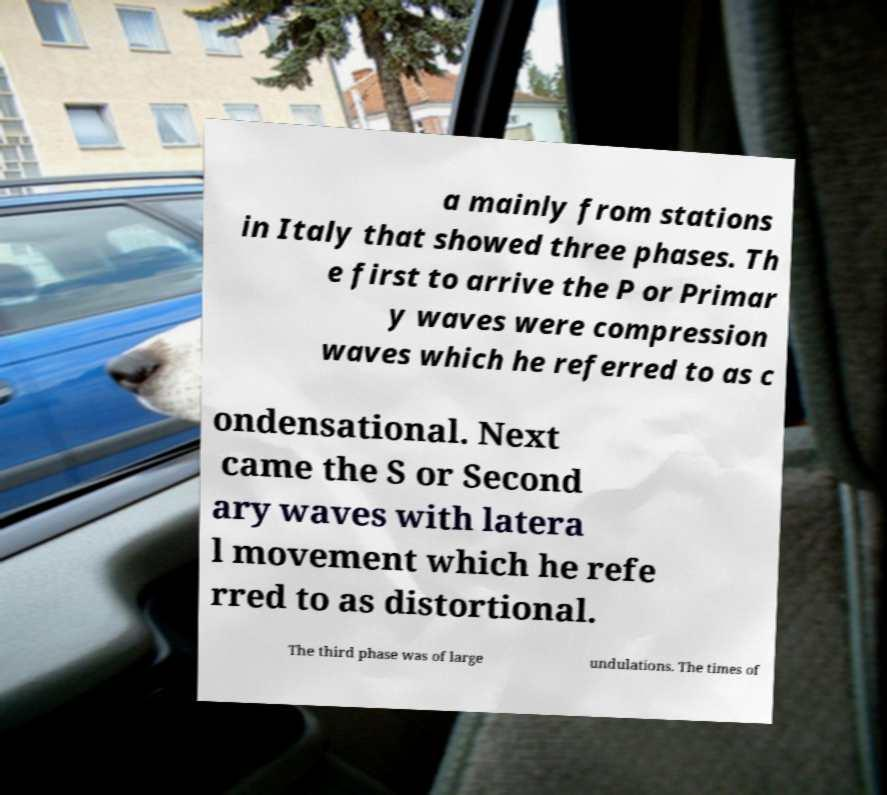I need the written content from this picture converted into text. Can you do that? a mainly from stations in Italy that showed three phases. Th e first to arrive the P or Primar y waves were compression waves which he referred to as c ondensational. Next came the S or Second ary waves with latera l movement which he refe rred to as distortional. The third phase was of large undulations. The times of 